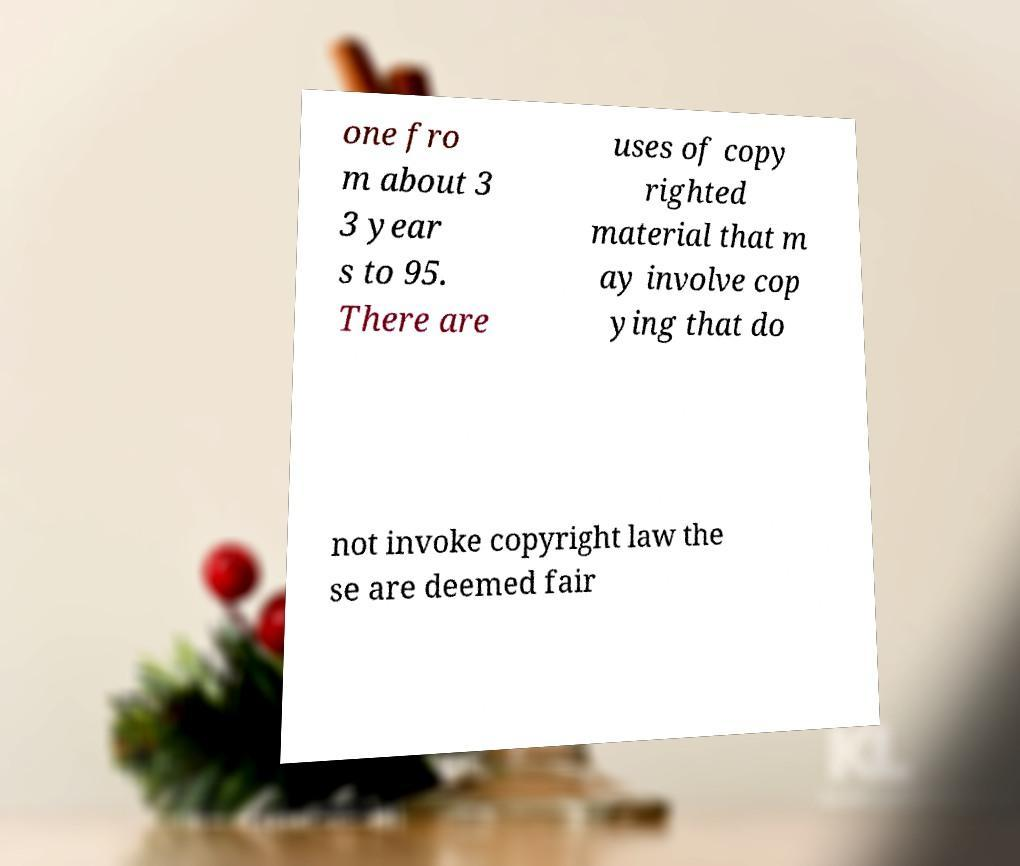Can you read and provide the text displayed in the image?This photo seems to have some interesting text. Can you extract and type it out for me? one fro m about 3 3 year s to 95. There are uses of copy righted material that m ay involve cop ying that do not invoke copyright law the se are deemed fair 